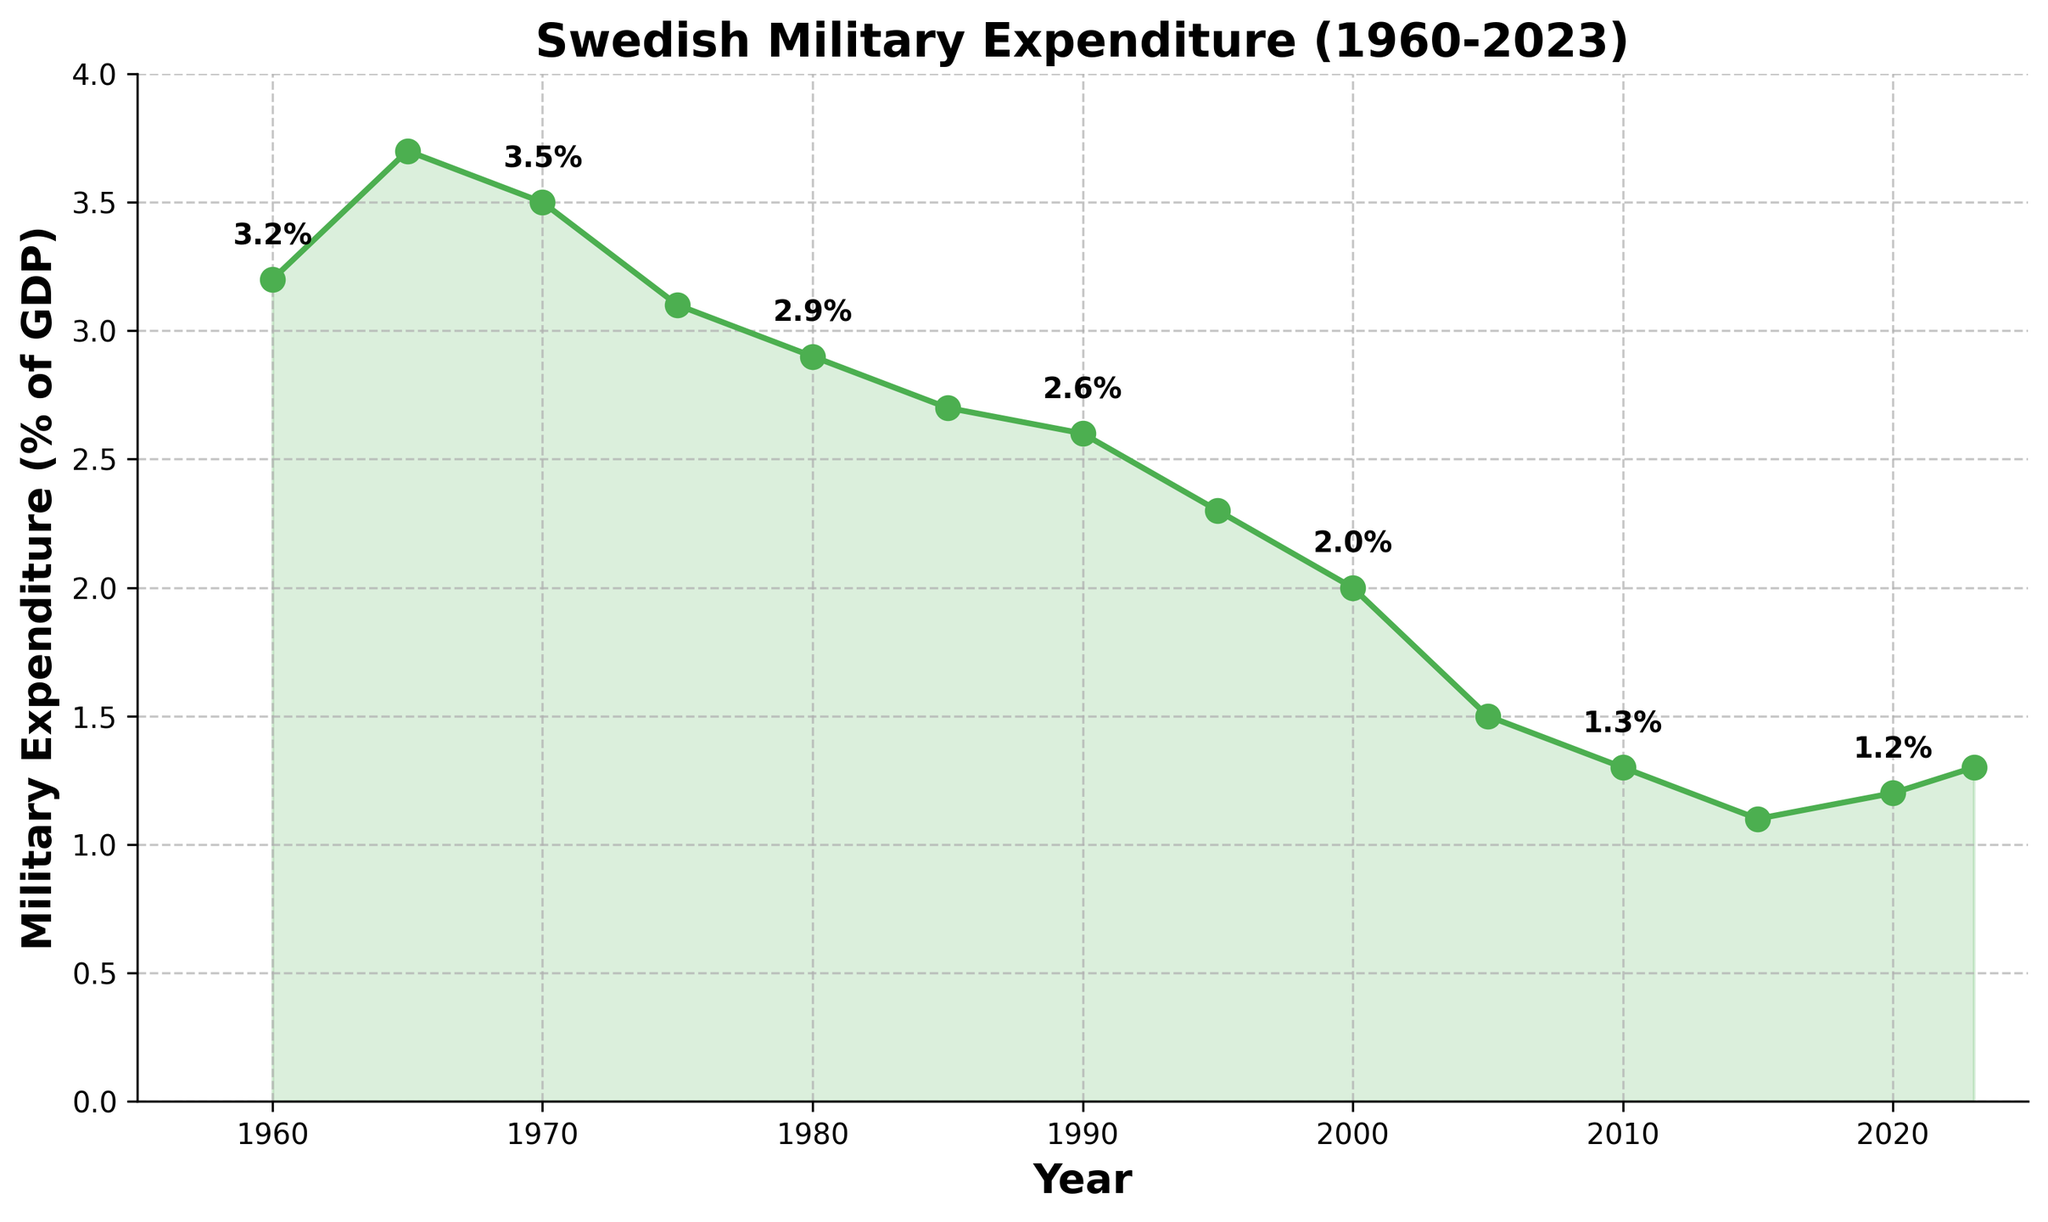What is the highest military expenditure as a percentage of GDP shown in the figure? The highest value on the y-axis that corresponds to military expenditure as a percentage of GDP is at 3.7% in 1965
Answer: 3.7% How did the military expenditure as a percentage of GDP change from 1965 to 1985? Compare the figures for 1965 (3.7%) and 1985 (2.7%) by calculating the difference as 3.7% - 2.7% = 1.0%. This shows a decrease of 1.0%
Answer: Decreased by 1.0% In which year did Sweden have the lowest military expenditure as a percentage of GDP? Identify the smallest y-axis value on the line chart, which is 1.1% in 2015
Answer: 2015 How many times did the military expenditure as a percentage of GDP decrease consecutively from one data point to the next? Identify and count consecutive descending segments: 3.7 to 3.5 (1965 to 1970), 3.5 to 3.1 (1970 to 1975), 3.1 to 2.9 (1975 to 1980), 2.9 to 2.7 (1980 to 1985), 2.7 to 2.6 (1985 to 1990), 2.6 to 2.3 (1990 to 1995), 2.3 to 2.0 (1995 to 2000), 2.0 to 1.5 (2000 to 2005), 1.5 to 1.3 (2005 to 2010), 1.3 to 1.1 (2010 to 2015) total to 10 times
Answer: 10 times What is the average military expenditure as a percentage of GDP between 1980 and 2000? Sum the values for 1980 (2.9%), 1985 (2.7%), 1990 (2.6%), 1995 (2.3%), and 2000 (2.0%) to get 12.5%. Divide by 5 to get the average: 12.5% / 5 = 2.5%
Answer: 2.5% How did the military expenditure change between 2020 and 2023? Compare values for 2020 (1.2%) and 2023 (1.3%) to find the change: 1.3% - 1.2% = 0.1%, indicating a slight increase
Answer: Increased by 0.1% During which decade did Sweden experience the most significant decrease in military expenditure as a percentage of GDP? By comparing the differences in percentage for each decade: 
- 1960-1970: 3.2% to 3.5% (+0.3%)
- 1970-1980: 3.5% to 2.9% (-0.6%)
- 1980-1990: 2.9% to 2.6% (-0.3%)
- 1990-2000: 2.6% to 2.0% (-0.6%)
- 2000-2010: 2.0% to 1.3% (-0.7%)
- 2010-2020: 1.3% to 1.2% (-0.1%)
The 2000-2010 decade has the most significant decrease of 0.7%
Answer: 2000-2010 Which year marks the beginning of a rise in military expenditure after 2015? Identify the data point after 2015 with an increase, which occurs in 2020 when it rises from 1.1% in 2015 to 1.2%
Answer: 2020 